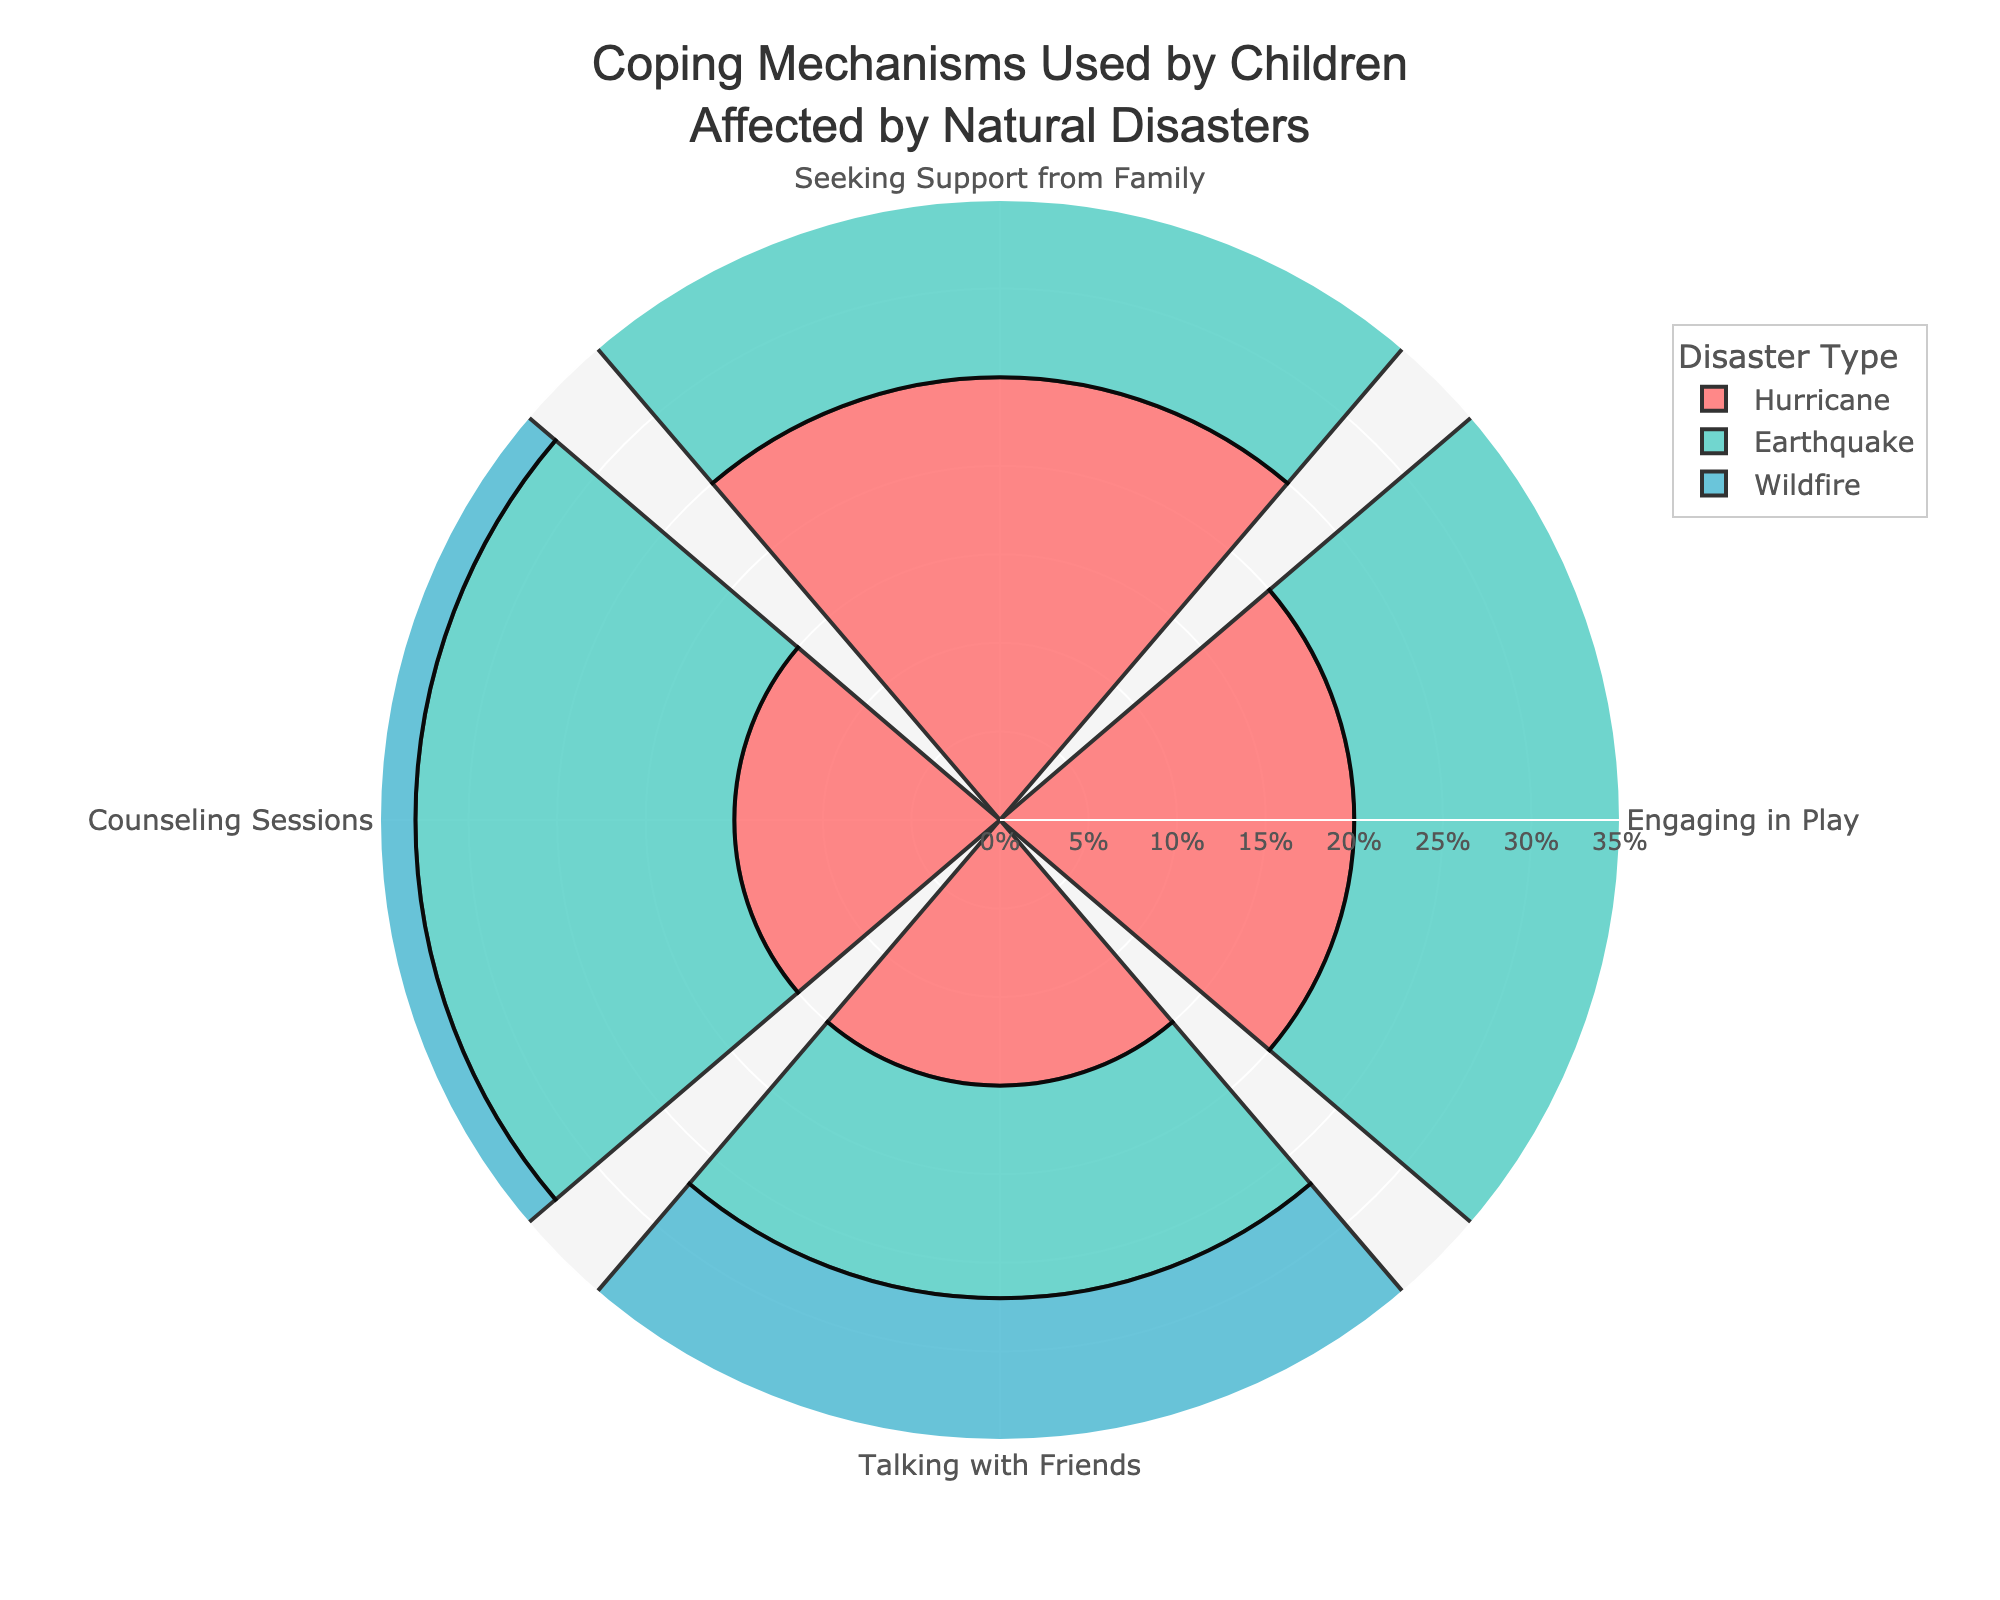What is the most common coping mechanism used by children affected by hurricanes? To determine the most common coping mechanism, look at the length of each bar representing the hurricane category in the polar area chart and find the one with the largest radius.
Answer: Seeking Support from Family Which natural disaster shows the highest percentage of children engaging in play as a coping mechanism? Examine the bars labeled for "Engaging in Play" in the polar area chart and identify the longest bar.
Answer: Wildfire Compare the percentage of children engaging in play between earthquakes and hurricanes. Which is higher? Compare the bars for "Engaging in Play" under both earthquake and hurricane categories and see which has a longer radius.
Answer: Hurricane How does the use of counseling sessions as a coping mechanism differ between children affected by wildfires and those affected by earthquakes? Compare the bars for "Counseling Sessions" in both wildfire and earthquake categories to see their respective lengths.
Answer: They are equal What is the combined percentage of children seeking support from family across all disaster types? Sum up the percentages of "Seeking Support from Family" for hurricanes, earthquakes, and wildfires (25 + 30 + 28).
Answer: 83% What coping mechanism has the lowest percentage among children affected by wildfires? Identify the shortest bar in the category for wildfires on the polar area chart.
Answer: Talking with Friends Which disaster type has children with the highest percentage of seeking family support? Look at the bars for "Seeking Support from Family" across all disaster types and find the highest one.
Answer: Earthquake Determine the average percentage of children engaging in play across all disaster types. Calculate the average by adding the percentages for "Engaging in Play" for hurricanes, earthquakes, and wildfires, and then dividing by 3 (20 + 18 + 22) / 3.
Answer: 20% How does the percentage of children engaging in play for hurricanes compare to the total average percentage of coping mechanisms used for all reported categories in hurricanes? Sum the individual percentages for all coping mechanisms in hurricanes and calculate their average. Compare this with the percentage of children engaging in play.
Answer: It's exactly the same Identify the disaster type where children talk with friends the least and provide the percentage. Look at the bars for "Talking with Friends" across all disaster types and find the shortest one.
Answer: Wildfire, 10% 